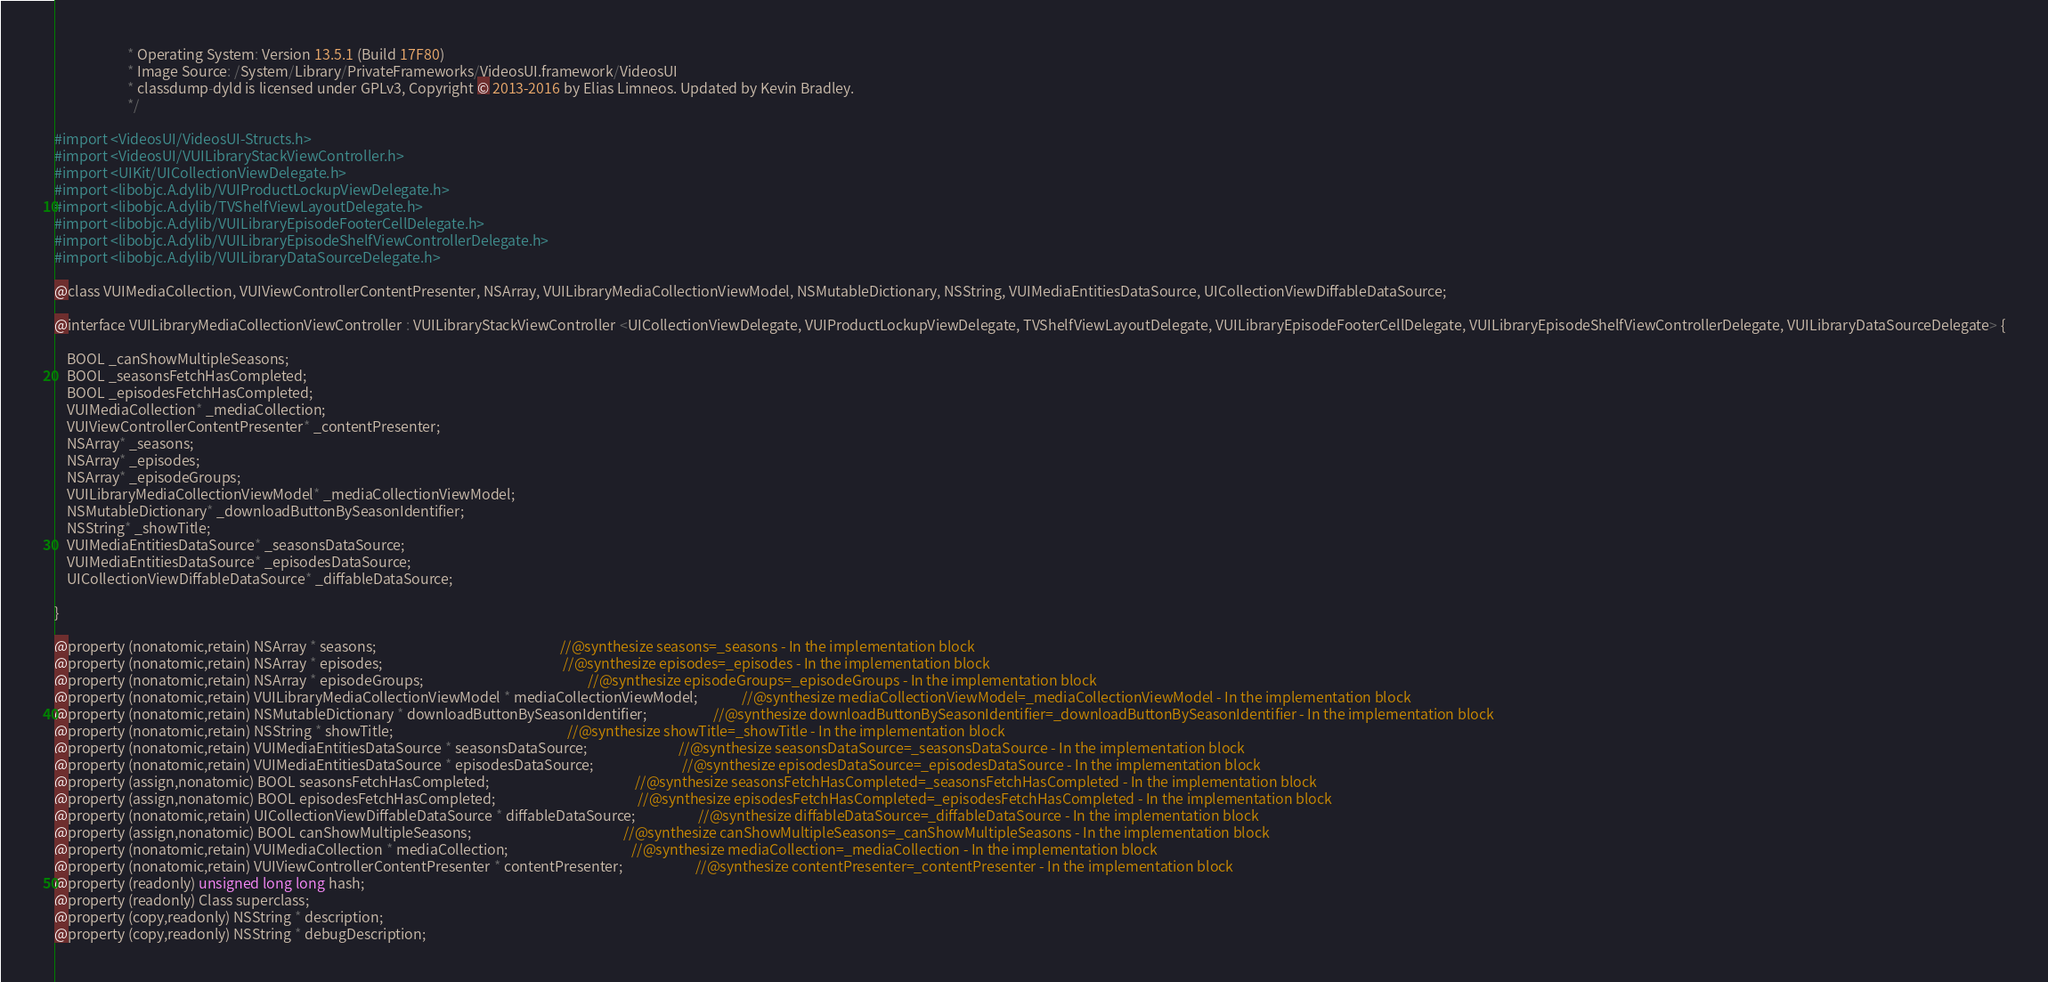Convert code to text. <code><loc_0><loc_0><loc_500><loc_500><_C_>                       * Operating System: Version 13.5.1 (Build 17F80)
                       * Image Source: /System/Library/PrivateFrameworks/VideosUI.framework/VideosUI
                       * classdump-dyld is licensed under GPLv3, Copyright © 2013-2016 by Elias Limneos. Updated by Kevin Bradley.
                       */

#import <VideosUI/VideosUI-Structs.h>
#import <VideosUI/VUILibraryStackViewController.h>
#import <UIKit/UICollectionViewDelegate.h>
#import <libobjc.A.dylib/VUIProductLockupViewDelegate.h>
#import <libobjc.A.dylib/TVShelfViewLayoutDelegate.h>
#import <libobjc.A.dylib/VUILibraryEpisodeFooterCellDelegate.h>
#import <libobjc.A.dylib/VUILibraryEpisodeShelfViewControllerDelegate.h>
#import <libobjc.A.dylib/VUILibraryDataSourceDelegate.h>

@class VUIMediaCollection, VUIViewControllerContentPresenter, NSArray, VUILibraryMediaCollectionViewModel, NSMutableDictionary, NSString, VUIMediaEntitiesDataSource, UICollectionViewDiffableDataSource;

@interface VUILibraryMediaCollectionViewController : VUILibraryStackViewController <UICollectionViewDelegate, VUIProductLockupViewDelegate, TVShelfViewLayoutDelegate, VUILibraryEpisodeFooterCellDelegate, VUILibraryEpisodeShelfViewControllerDelegate, VUILibraryDataSourceDelegate> {

	BOOL _canShowMultipleSeasons;
	BOOL _seasonsFetchHasCompleted;
	BOOL _episodesFetchHasCompleted;
	VUIMediaCollection* _mediaCollection;
	VUIViewControllerContentPresenter* _contentPresenter;
	NSArray* _seasons;
	NSArray* _episodes;
	NSArray* _episodeGroups;
	VUILibraryMediaCollectionViewModel* _mediaCollectionViewModel;
	NSMutableDictionary* _downloadButtonBySeasonIdentifier;
	NSString* _showTitle;
	VUIMediaEntitiesDataSource* _seasonsDataSource;
	VUIMediaEntitiesDataSource* _episodesDataSource;
	UICollectionViewDiffableDataSource* _diffableDataSource;

}

@property (nonatomic,retain) NSArray * seasons;                                                          //@synthesize seasons=_seasons - In the implementation block
@property (nonatomic,retain) NSArray * episodes;                                                         //@synthesize episodes=_episodes - In the implementation block
@property (nonatomic,retain) NSArray * episodeGroups;                                                    //@synthesize episodeGroups=_episodeGroups - In the implementation block
@property (nonatomic,retain) VUILibraryMediaCollectionViewModel * mediaCollectionViewModel;              //@synthesize mediaCollectionViewModel=_mediaCollectionViewModel - In the implementation block
@property (nonatomic,retain) NSMutableDictionary * downloadButtonBySeasonIdentifier;                     //@synthesize downloadButtonBySeasonIdentifier=_downloadButtonBySeasonIdentifier - In the implementation block
@property (nonatomic,retain) NSString * showTitle;                                                       //@synthesize showTitle=_showTitle - In the implementation block
@property (nonatomic,retain) VUIMediaEntitiesDataSource * seasonsDataSource;                             //@synthesize seasonsDataSource=_seasonsDataSource - In the implementation block
@property (nonatomic,retain) VUIMediaEntitiesDataSource * episodesDataSource;                            //@synthesize episodesDataSource=_episodesDataSource - In the implementation block
@property (assign,nonatomic) BOOL seasonsFetchHasCompleted;                                              //@synthesize seasonsFetchHasCompleted=_seasonsFetchHasCompleted - In the implementation block
@property (assign,nonatomic) BOOL episodesFetchHasCompleted;                                             //@synthesize episodesFetchHasCompleted=_episodesFetchHasCompleted - In the implementation block
@property (nonatomic,retain) UICollectionViewDiffableDataSource * diffableDataSource;                    //@synthesize diffableDataSource=_diffableDataSource - In the implementation block
@property (assign,nonatomic) BOOL canShowMultipleSeasons;                                                //@synthesize canShowMultipleSeasons=_canShowMultipleSeasons - In the implementation block
@property (nonatomic,retain) VUIMediaCollection * mediaCollection;                                       //@synthesize mediaCollection=_mediaCollection - In the implementation block
@property (nonatomic,retain) VUIViewControllerContentPresenter * contentPresenter;                       //@synthesize contentPresenter=_contentPresenter - In the implementation block
@property (readonly) unsigned long long hash; 
@property (readonly) Class superclass; 
@property (copy,readonly) NSString * description; 
@property (copy,readonly) NSString * debugDescription; </code> 